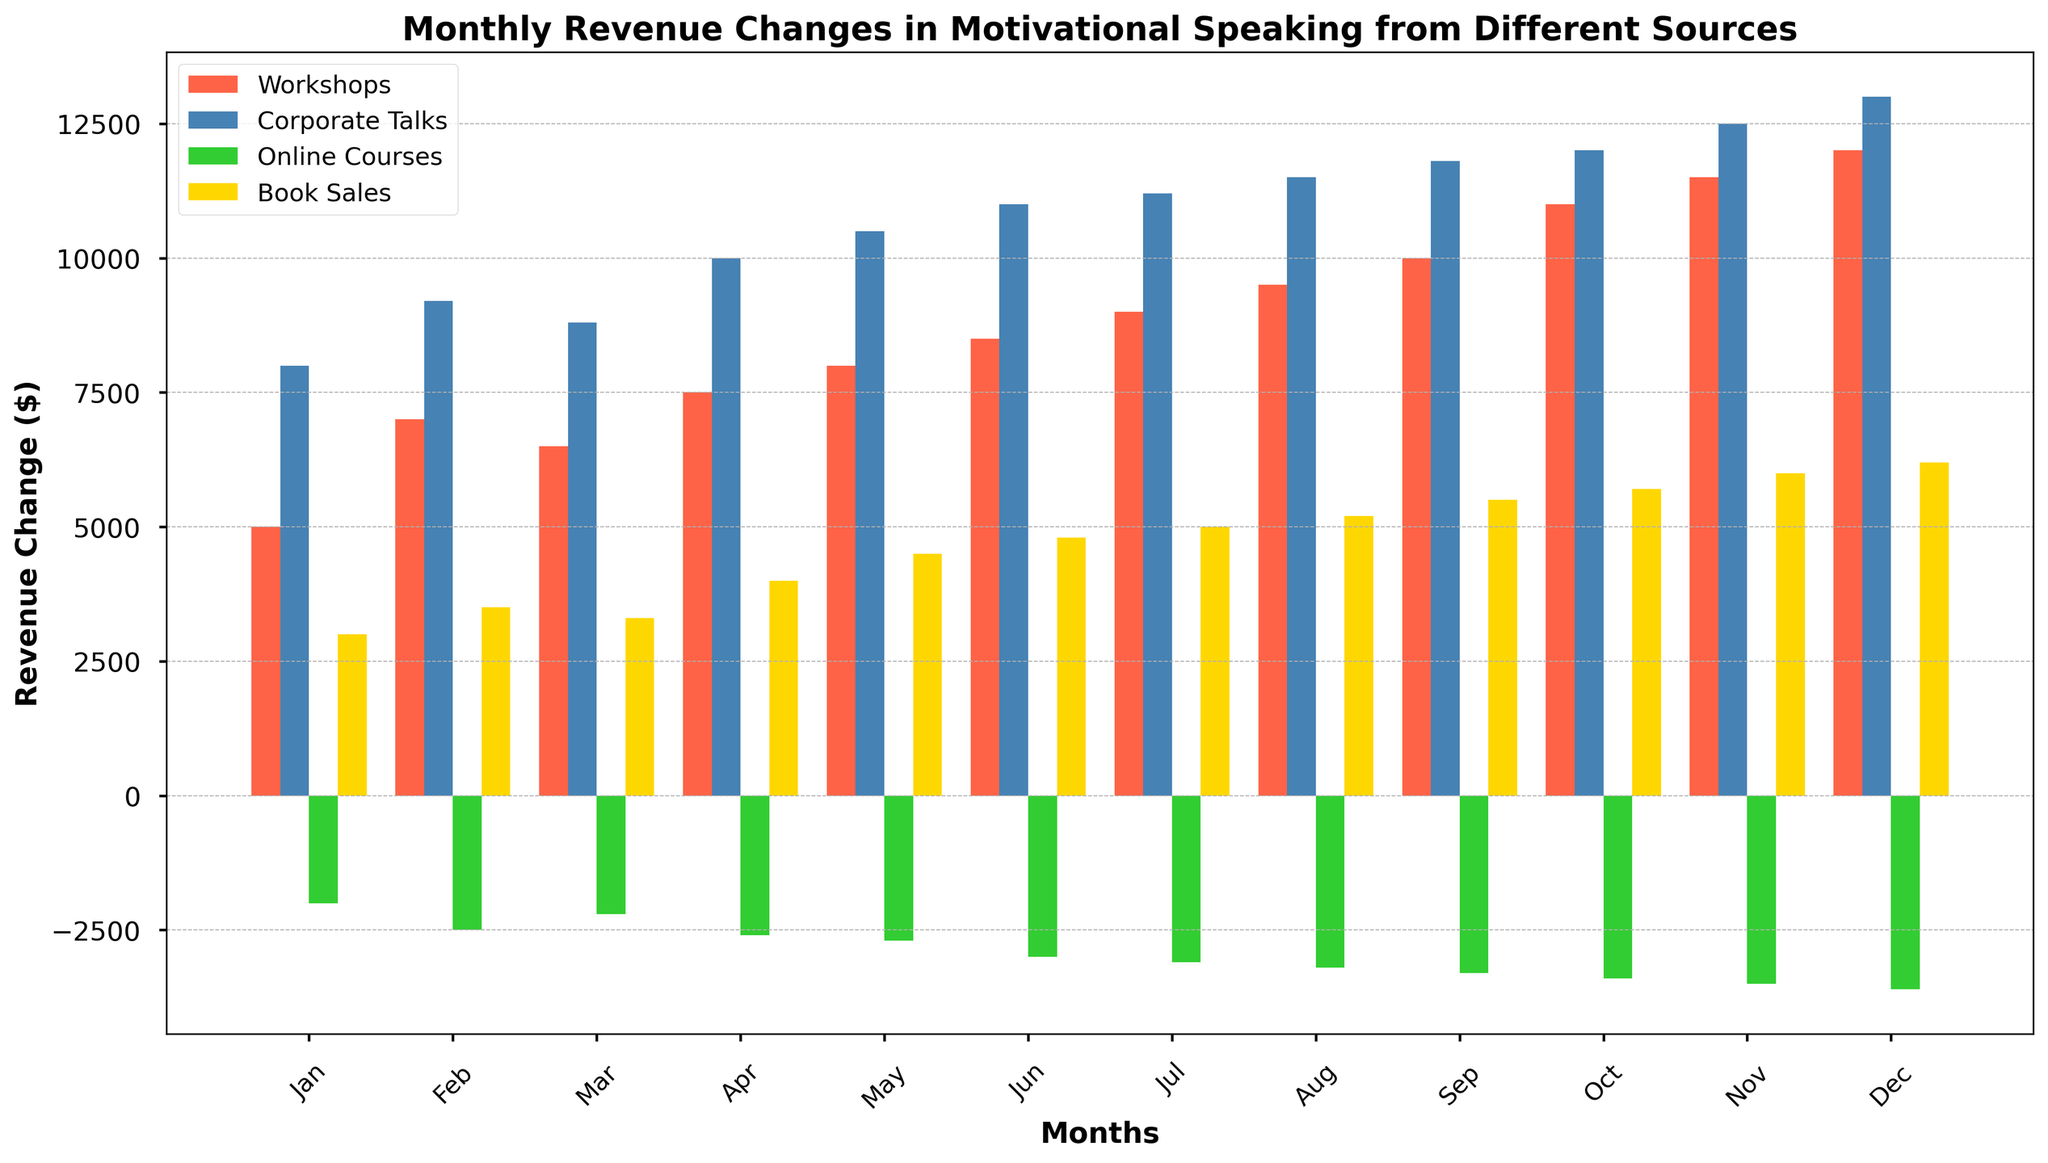What is the month with the highest revenue change from Book Sales? The yellow bars represent Book Sales. The highest yellow bar is in December.
Answer: December Which revenue source had negative values? Observing the colors, the green bars (Online Courses) consistently go below the x-axis, indicating negative values.
Answer: Online Courses In which month did Workshops and Corporate Talks both have over $10,000 revenue change? The red and blue bars need to be above the $10,000 mark. In October, both Workshops (11,000) and Corporate Talks (12,000) surpass this mark.
Answer: October What is the total revenue change from Workshops and Corporate Talks in June? Add the red and blue bars for June: 8,500 (Workshops) + 11,000 (Corporate Talks) = 19,500.
Answer: 19,500 How does the revenue change from Online Courses in March compare to that in December? The green bar in March is slightly above -2,200 and in December it is -3,600. Since -2,200 is larger than -3,600, Online Courses had a better revenue change in March.
Answer: March is better Which two months have the greatest difference in Corporate Talks revenue change? Identify the blue bars with highest and lowest values. December (13,000) and January (8,000) have the greatest difference: 13,000 - 8,000 = 5,000.
Answer: December and January In which month did Workshops generate the lowest revenue change? The shortest red bar corresponds to January, showing it generated the lowest revenue change.
Answer: January Is there any month where book sales were higher than workshops revenue? Compare corresponding yellow and red bars. No yellow bar is higher than the red ones.
Answer: No 